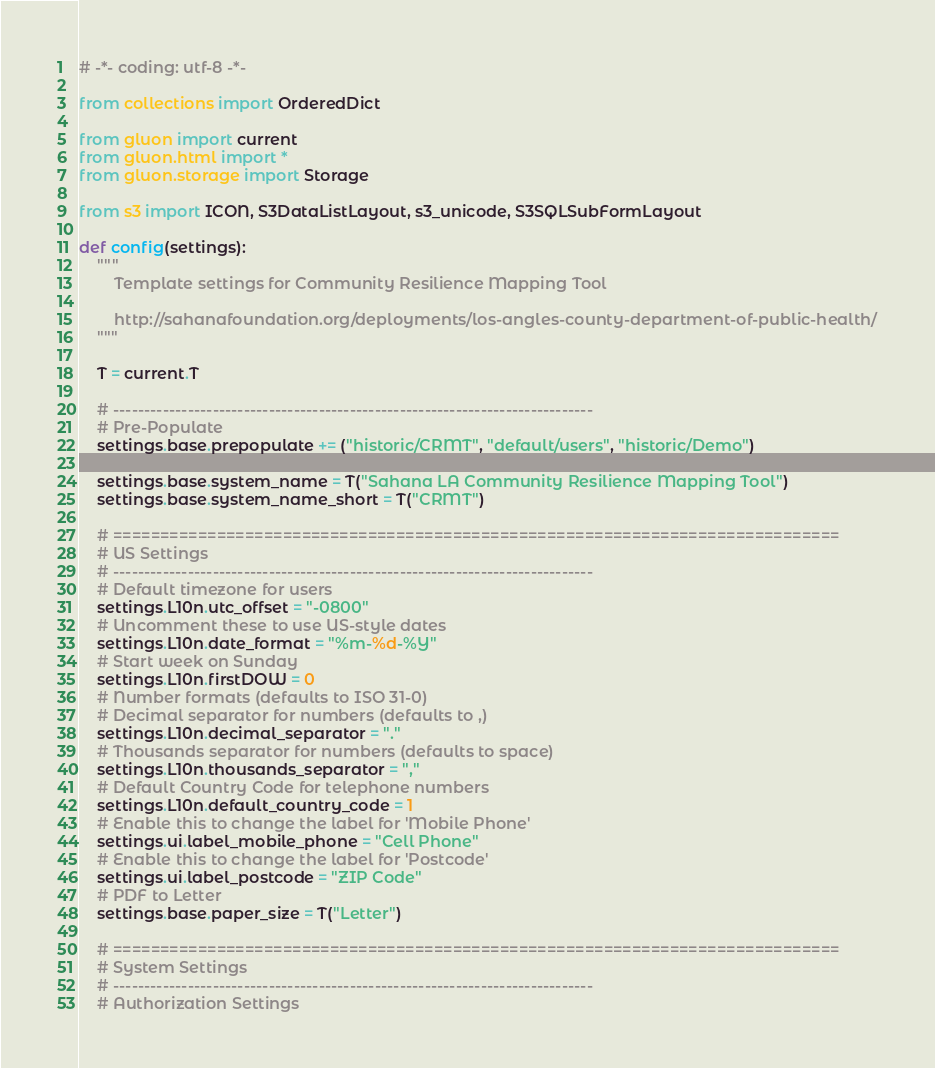<code> <loc_0><loc_0><loc_500><loc_500><_Python_># -*- coding: utf-8 -*-

from collections import OrderedDict

from gluon import current
from gluon.html import *
from gluon.storage import Storage

from s3 import ICON, S3DataListLayout, s3_unicode, S3SQLSubFormLayout

def config(settings):
    """
        Template settings for Community Resilience Mapping Tool

        http://sahanafoundation.org/deployments/los-angles-county-department-of-public-health/
    """

    T = current.T

    # -----------------------------------------------------------------------------
    # Pre-Populate
    settings.base.prepopulate += ("historic/CRMT", "default/users", "historic/Demo")

    settings.base.system_name = T("Sahana LA Community Resilience Mapping Tool")
    settings.base.system_name_short = T("CRMT")

    # =============================================================================
    # US Settings
    # -----------------------------------------------------------------------------
    # Default timezone for users
    settings.L10n.utc_offset = "-0800"
    # Uncomment these to use US-style dates
    settings.L10n.date_format = "%m-%d-%Y"
    # Start week on Sunday
    settings.L10n.firstDOW = 0
    # Number formats (defaults to ISO 31-0)
    # Decimal separator for numbers (defaults to ,)
    settings.L10n.decimal_separator = "."
    # Thousands separator for numbers (defaults to space)
    settings.L10n.thousands_separator = ","
    # Default Country Code for telephone numbers
    settings.L10n.default_country_code = 1
    # Enable this to change the label for 'Mobile Phone'
    settings.ui.label_mobile_phone = "Cell Phone"
    # Enable this to change the label for 'Postcode'
    settings.ui.label_postcode = "ZIP Code"
    # PDF to Letter
    settings.base.paper_size = T("Letter")

    # =============================================================================
    # System Settings
    # -----------------------------------------------------------------------------
    # Authorization Settings</code> 